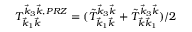<formula> <loc_0><loc_0><loc_500><loc_500>T _ { \vec { k } _ { 1 } \vec { k } } ^ { \vec { k } _ { 3 } \vec { k } , P R Z } = ( \tilde { T } _ { \vec { k } _ { 1 } \vec { k } } ^ { \vec { k } _ { 3 } \vec { k } } + \tilde { T } _ { \vec { k } \vec { k } _ { 1 } } ^ { \vec { k } _ { 3 } \vec { k } } ) / 2</formula> 